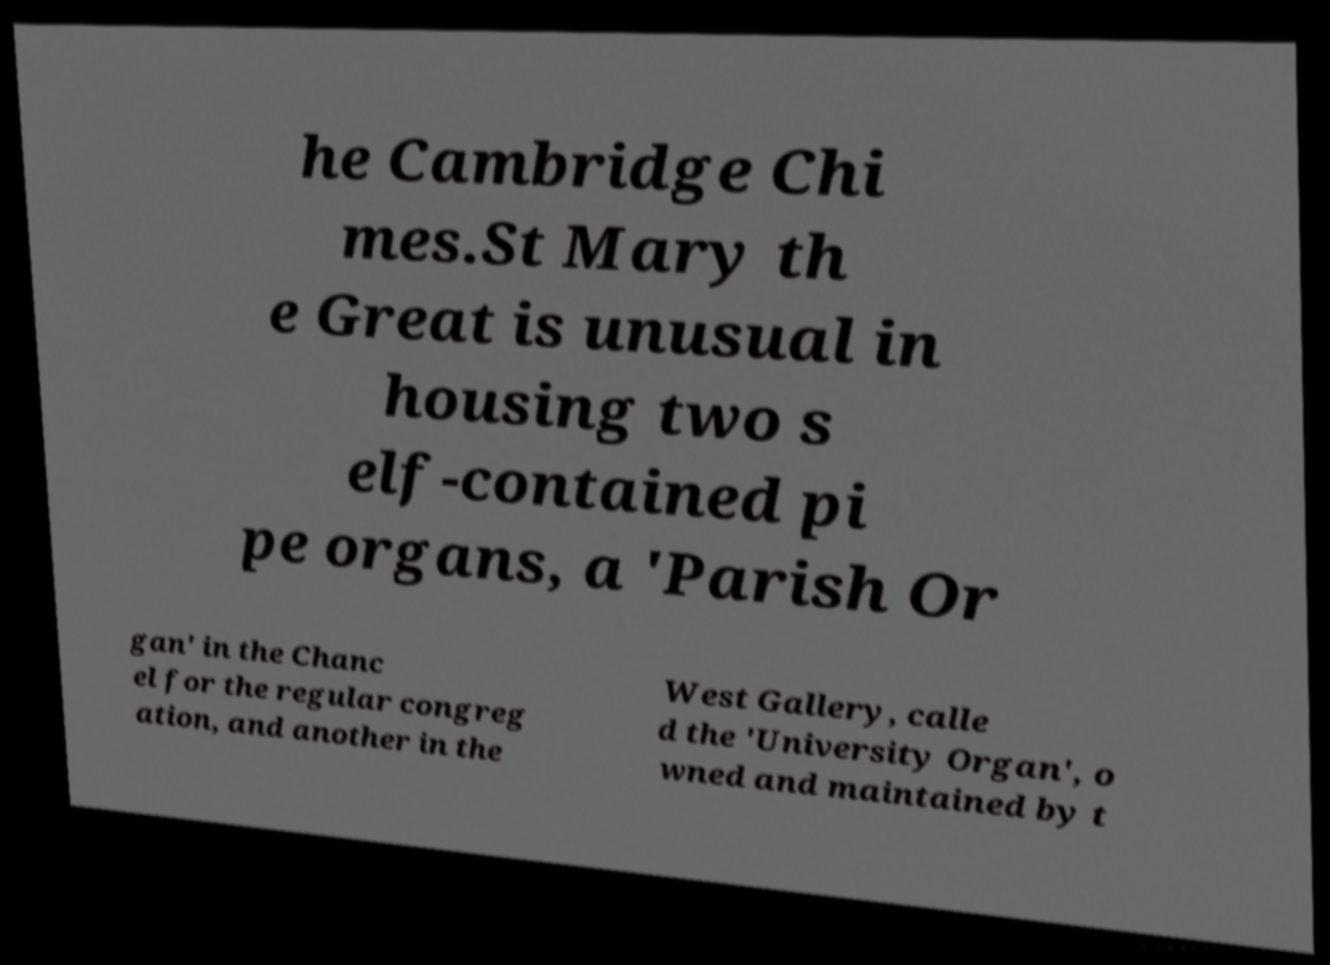There's text embedded in this image that I need extracted. Can you transcribe it verbatim? he Cambridge Chi mes.St Mary th e Great is unusual in housing two s elf-contained pi pe organs, a 'Parish Or gan' in the Chanc el for the regular congreg ation, and another in the West Gallery, calle d the 'University Organ', o wned and maintained by t 